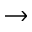<formula> <loc_0><loc_0><loc_500><loc_500>\rightarrow</formula> 